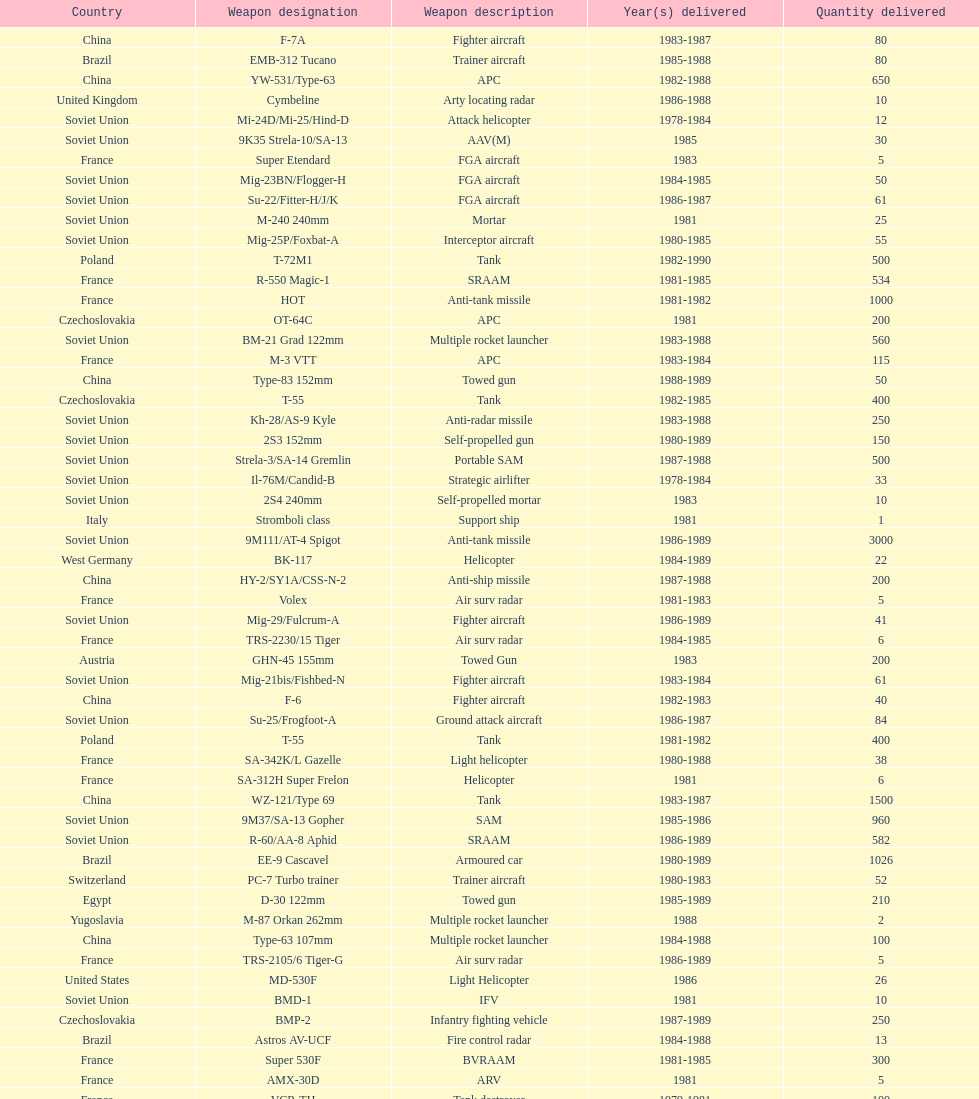According to this list, how many countries sold weapons to iraq? 21. 